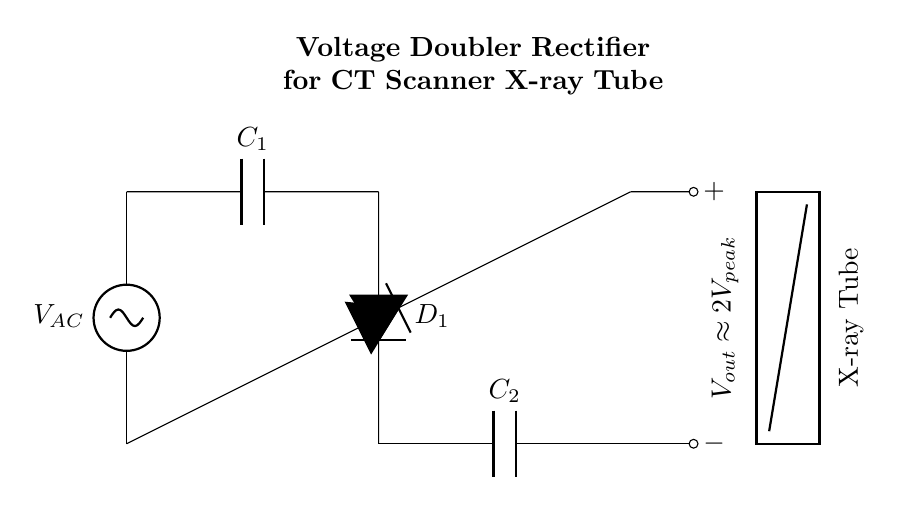What is the function of the capacitors in this circuit? The capacitors in the circuit act as storage components, charging up during the positive half of the AC cycle and providing a higher voltage output during the negative cycle. Specifically, C1 charges when D1 conducts, and C2 is charged from the output voltage, effectively doubling the voltage.
Answer: Storage components What is the output voltage of this circuit? The output voltage is approximately double the peak voltage of the AC supply, as indicated in the circuit diagram. During operation, the arrangement allows for this increased voltage to be delivered to the load.
Answer: Approximately two times peak voltage How many diodes are present in this circuit? There are two diodes in the circuit, D1 and the diode connected to the X-ray tube, used to rectify the AC input voltage. Both diodes ensure current can flow in one direction, necessary for converting AC to DC.
Answer: Two What type of circuit is this? This circuit is a voltage doubler rectifier, designed specifically to enhance output voltage, making it suitable for high-voltage applications, such as powering an X-ray tube. The configuration focuses on maximally utilizing the input AC voltage.
Answer: Voltage doubler rectifier What does the X-ray tube represent in the circuit? The X-ray tube represents the load in the circuit that requires a high voltage for its operation. It utilizes the increased voltage supplied by the voltage doubler rectifier to produce X-rays for imaging applications.
Answer: Load for X-ray generation 